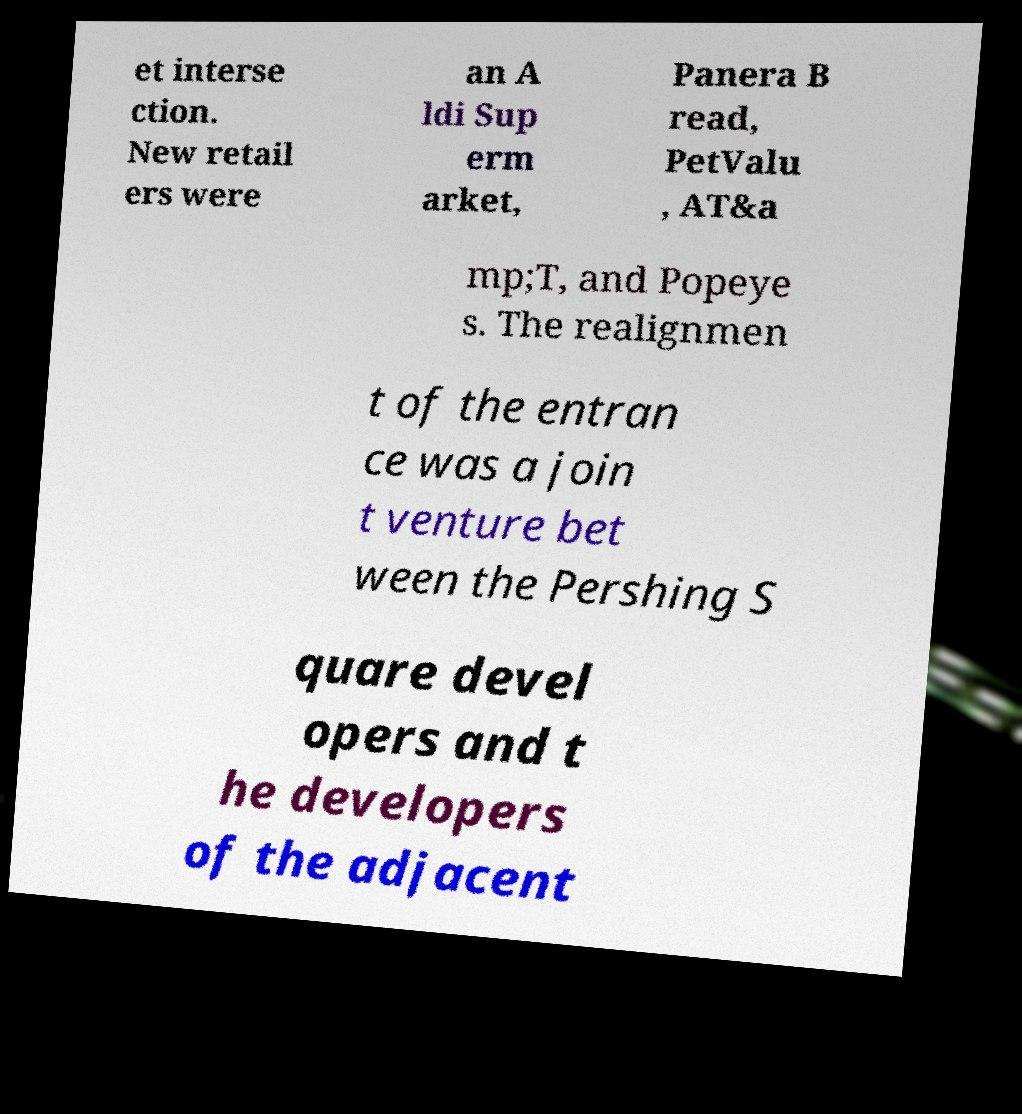Can you read and provide the text displayed in the image?This photo seems to have some interesting text. Can you extract and type it out for me? et interse ction. New retail ers were an A ldi Sup erm arket, Panera B read, PetValu , AT&a mp;T, and Popeye s. The realignmen t of the entran ce was a join t venture bet ween the Pershing S quare devel opers and t he developers of the adjacent 